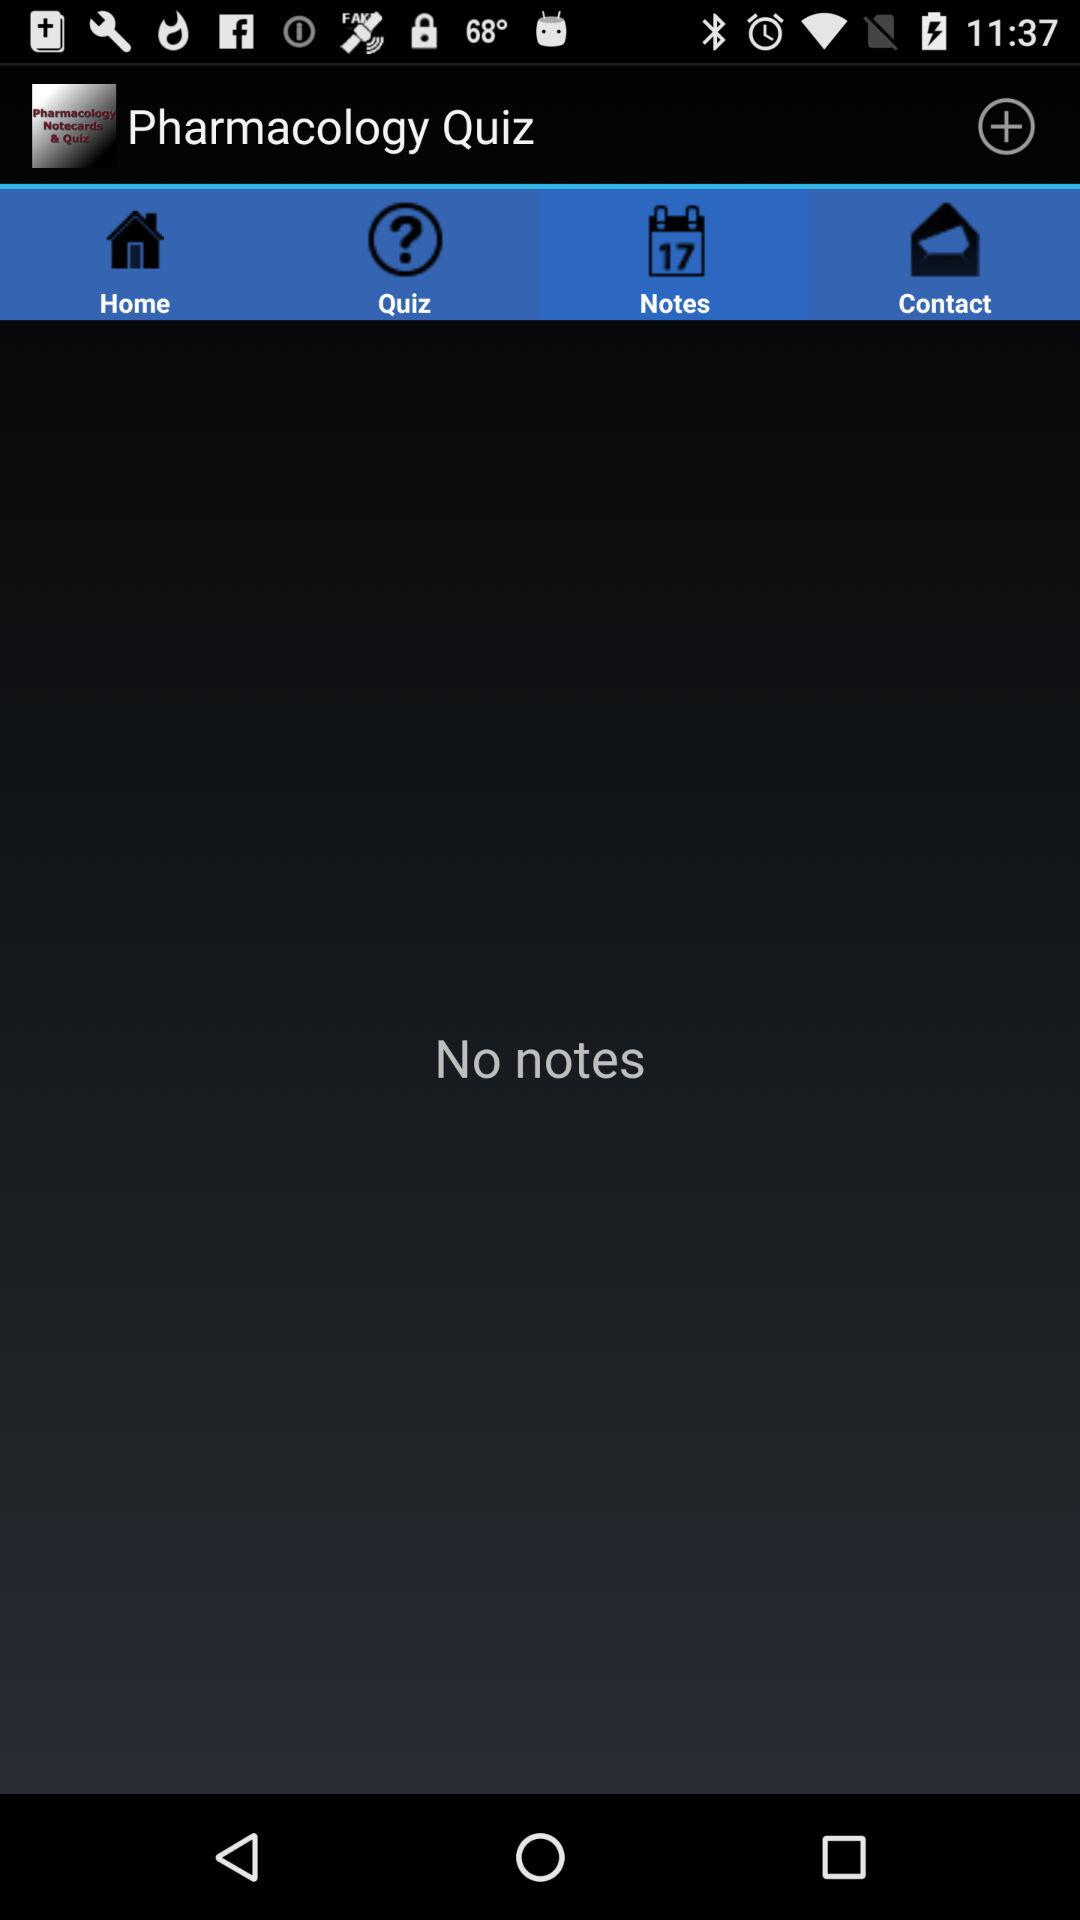What is the application name? The application name is "Pharmacology Quiz". 